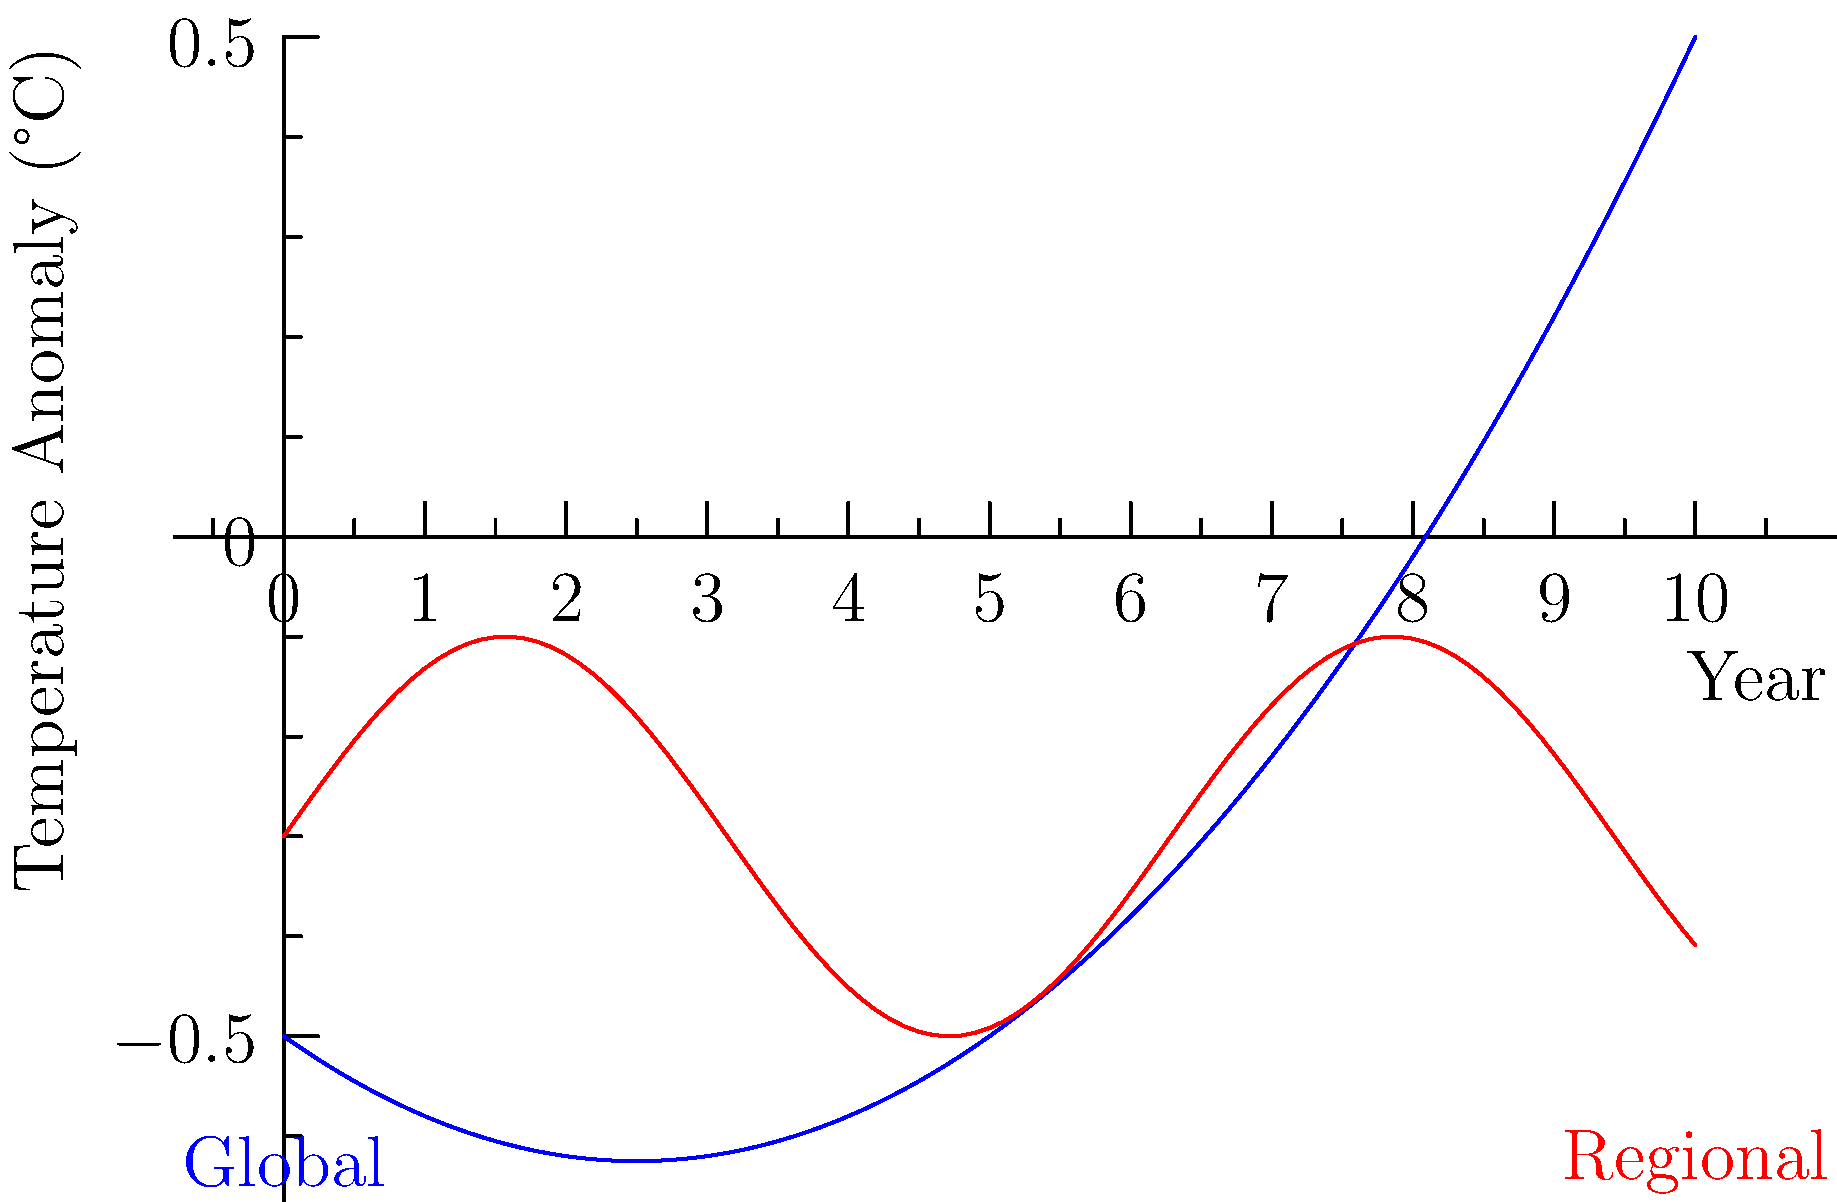Based on the graph showing global and regional temperature anomalies from 2010 to 2020, which trend line indicates a more consistent increase in temperature, and what might this imply about the effectiveness of global environmental policies? To answer this question, we need to analyze both trend lines:

1. Global trend (blue line):
   - Shows a clear upward curve
   - Starts below -0.5°C and ends above 1.5°C
   - The curve is smooth, indicating a consistent increase

2. Regional trend (red line):
   - Fluctuates up and down
   - Overall trend is slightly upward
   - Shows more variability and less consistency

3. Comparison:
   - The global trend shows a more consistent increase
   - The regional trend shows more short-term variability

4. Implications for global environmental policies:
   - The consistent global increase suggests that current global policies may not be effectively mitigating overall temperature rise
   - Regional fluctuations might be due to local factors or policies, but they don't offset the global trend
   - The divergence between global and regional trends highlights the need for both global and localized approaches to climate change mitigation

5. Conclusion:
   The global trend line indicates a more consistent increase in temperature. This implies that current global environmental policies may not be sufficiently effective in curbing the overall rise in global temperatures, despite potential regional variations.
Answer: Global trend; suggests insufficient effectiveness of current global environmental policies. 